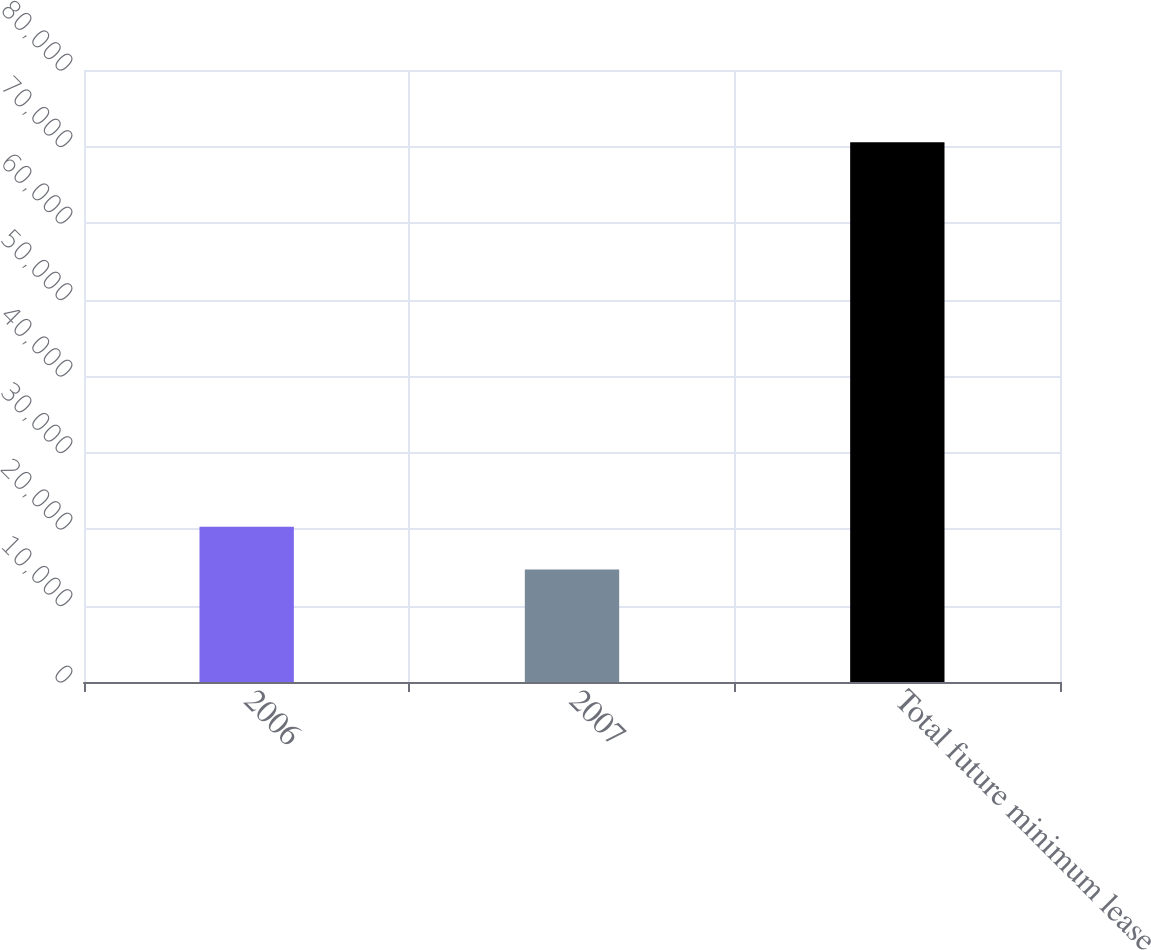Convert chart. <chart><loc_0><loc_0><loc_500><loc_500><bar_chart><fcel>2006<fcel>2007<fcel>Total future minimum lease<nl><fcel>20300.9<fcel>14716<fcel>70565<nl></chart> 